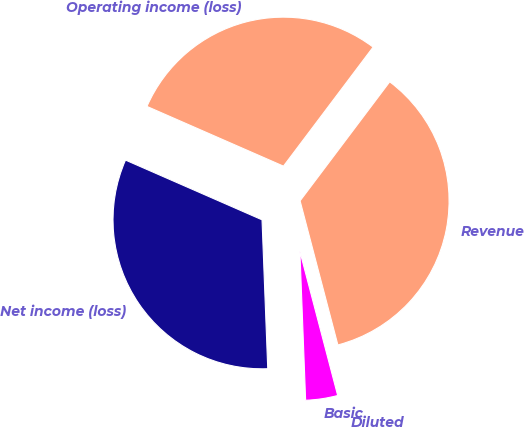<chart> <loc_0><loc_0><loc_500><loc_500><pie_chart><fcel>Revenue<fcel>Operating income (loss)<fcel>Net income (loss)<fcel>Basic<fcel>Diluted<nl><fcel>35.65%<fcel>28.71%<fcel>32.18%<fcel>3.47%<fcel>0.0%<nl></chart> 